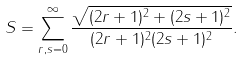<formula> <loc_0><loc_0><loc_500><loc_500>S = \sum _ { r , s = 0 } ^ { \infty } \frac { \sqrt { ( 2 r + 1 ) ^ { 2 } + ( 2 s + 1 ) ^ { 2 } } } { ( 2 r + 1 ) ^ { 2 } ( 2 s + 1 ) ^ { 2 } } .</formula> 